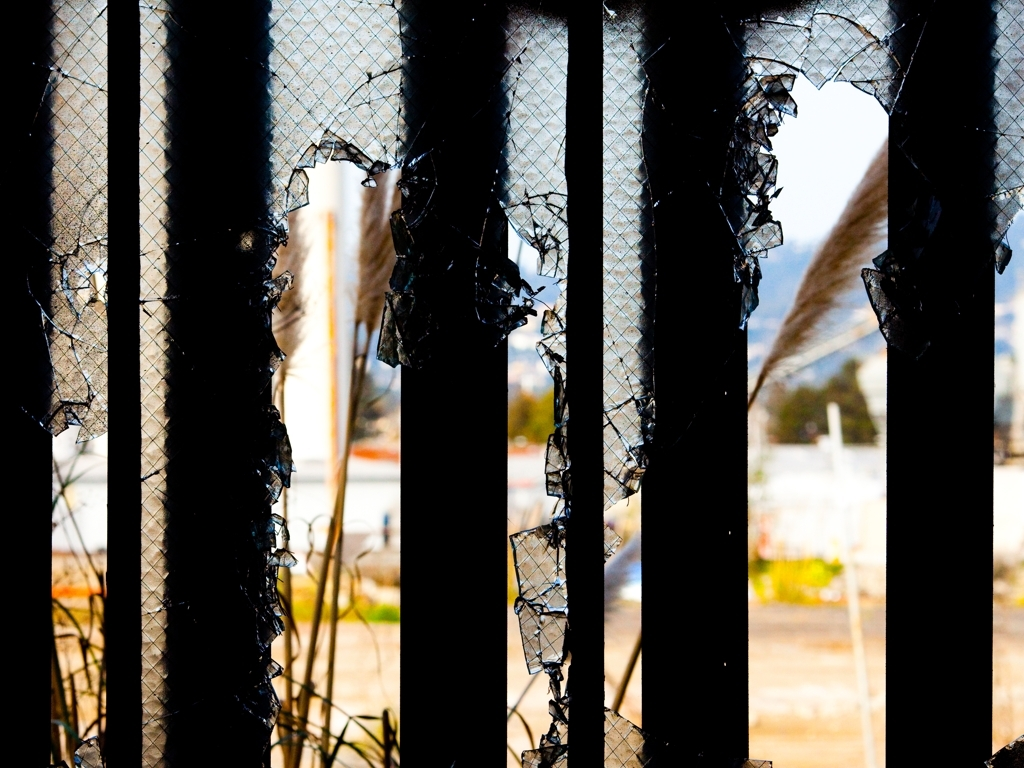Does this scene suggest any specific emotion or atmosphere? This image evokes a sense of abandonment and deterioration. The torn barrier against the backdrop of an indistinct urban setting creates a mood of neglect, indicating a space that has been overlooked and is in disrepair. 